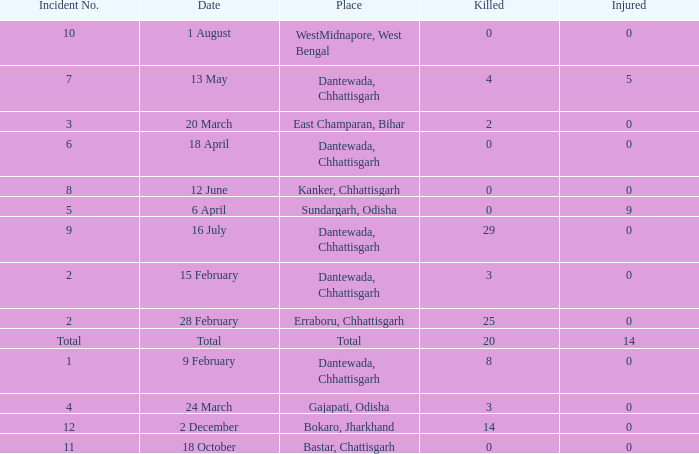How many people were injured in total in East Champaran, Bihar with more than 2 people killed? 0.0. 